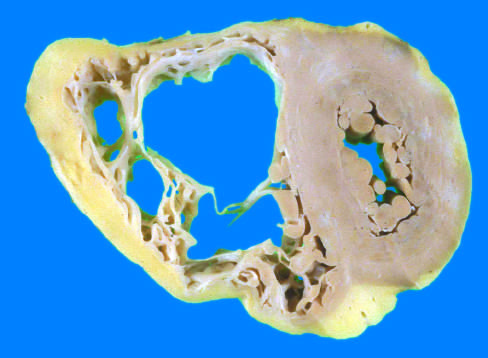does fish use a fluorescein-labeled cosmid probe for n-myc on a tissue section containing neuroblastoma have a grossly normal appearance in this heart?
Answer the question using a single word or phrase. No 